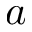Convert formula to latex. <formula><loc_0><loc_0><loc_500><loc_500>a</formula> 